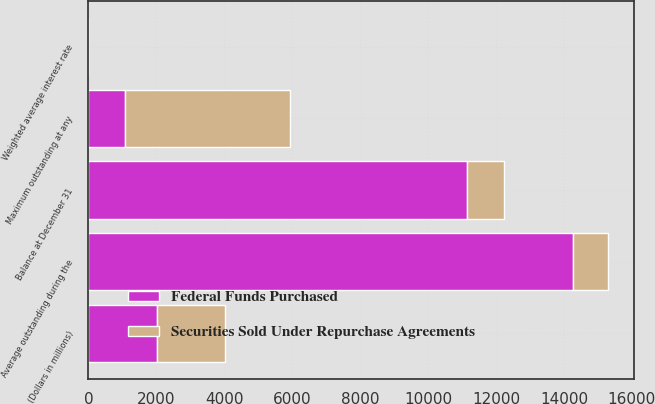<chart> <loc_0><loc_0><loc_500><loc_500><stacked_bar_chart><ecel><fcel>(Dollars in millions)<fcel>Balance at December 31<fcel>Maximum outstanding at any<fcel>Average outstanding during the<fcel>Weighted average interest rate<nl><fcel>Securities Sold Under Repurchase Agreements<fcel>2008<fcel>1082<fcel>4853<fcel>1026<fcel>1.77<nl><fcel>Federal Funds Purchased<fcel>2008<fcel>11154<fcel>1082<fcel>14261<fcel>1.24<nl></chart> 